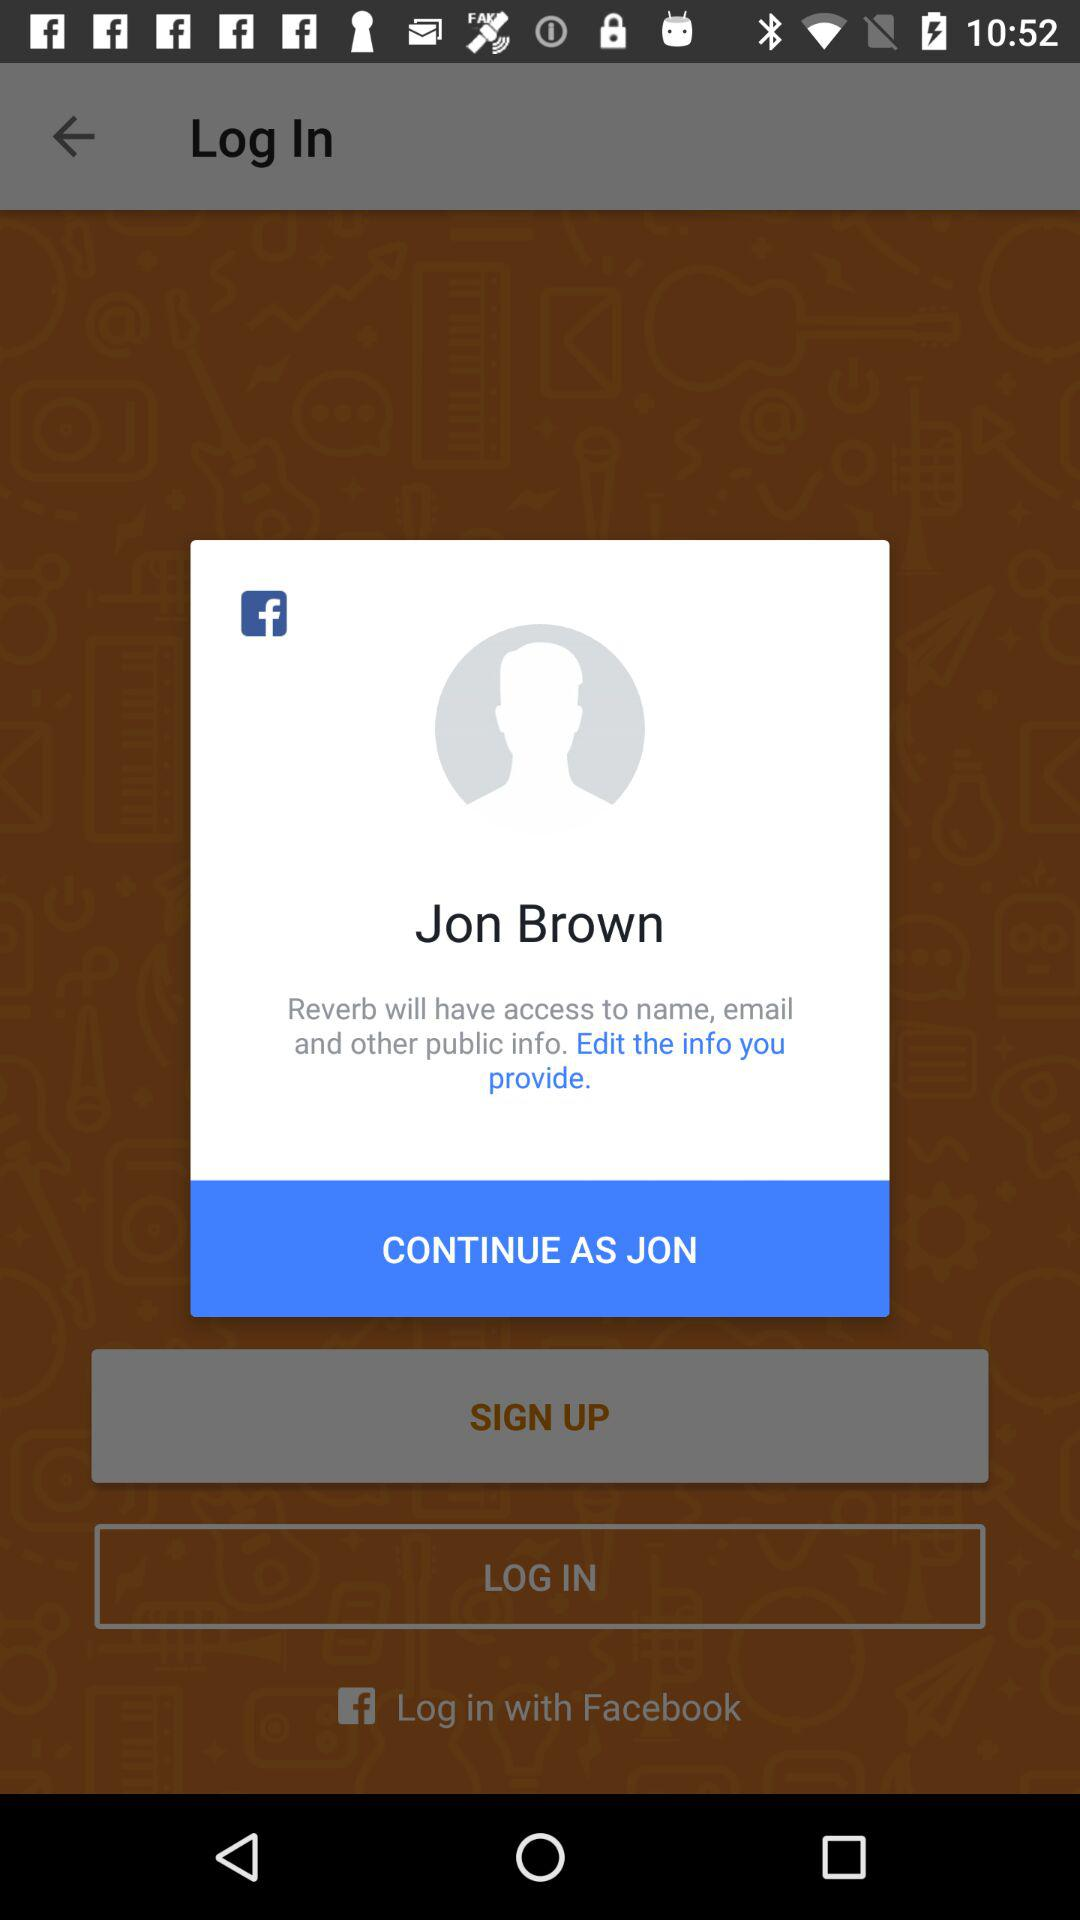How can we login? You can login with "Facebook". 